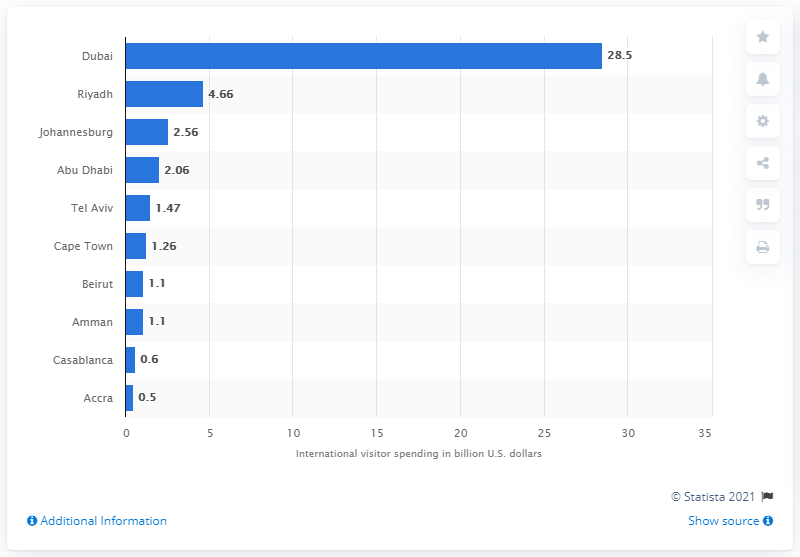Indicate a few pertinent items in this graphic. In 2016, Dubai spent approximately 28.5 billion USD on attracting and accommodating international visitors. In 2016, Dubai had the highest amount of international visitor spending. 